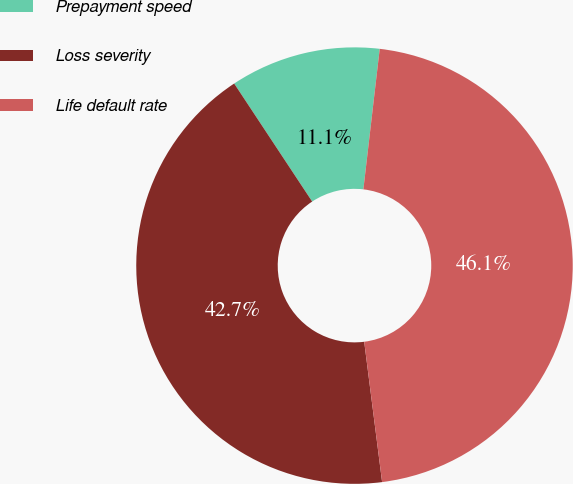<chart> <loc_0><loc_0><loc_500><loc_500><pie_chart><fcel>Prepayment speed<fcel>Loss severity<fcel>Life default rate<nl><fcel>11.14%<fcel>42.73%<fcel>46.14%<nl></chart> 